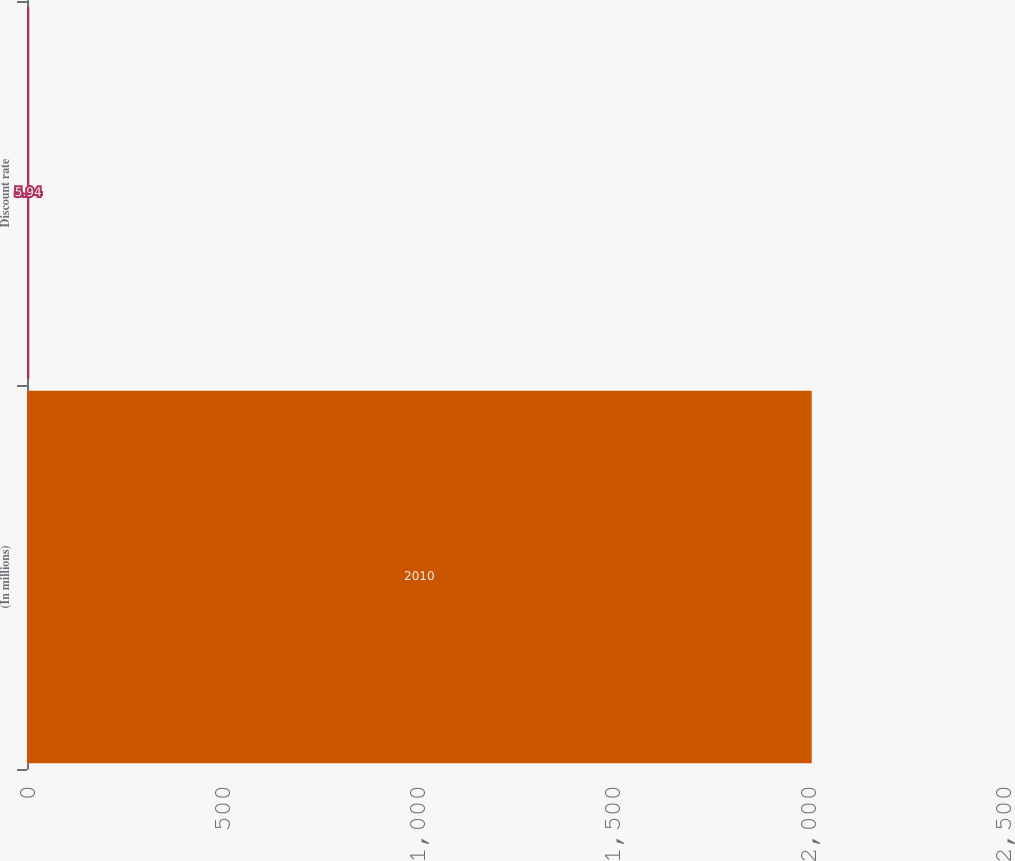<chart> <loc_0><loc_0><loc_500><loc_500><bar_chart><fcel>(In millions)<fcel>Discount rate<nl><fcel>2010<fcel>5.94<nl></chart> 